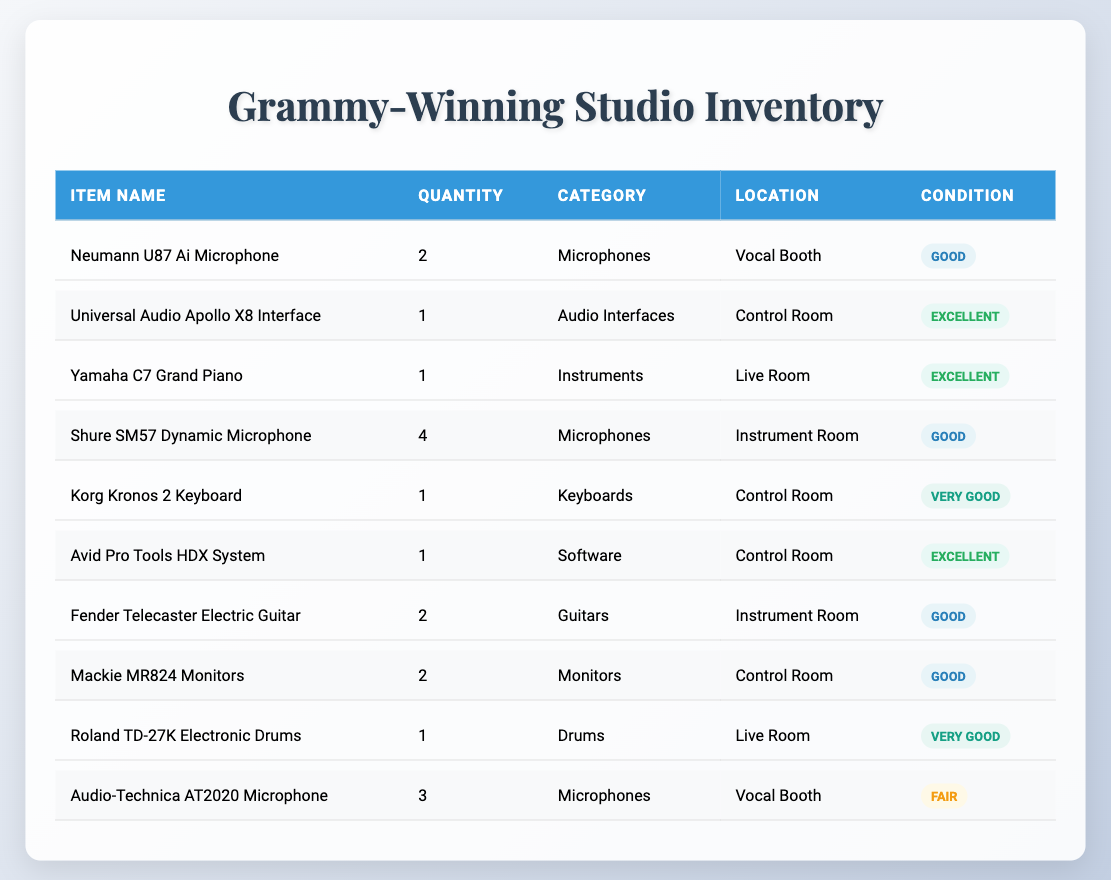What microphones are available in the Vocal Booth? The table lists two microphones in the Vocal Booth: Neumann U87 Ai Microphone (quantity 2) and Audio-Technica AT2020 Microphone (quantity 3).
Answer: Neumann U87 Ai Microphone and Audio-Technica AT2020 Microphone How many audio interfaces are there in the studio? There is 1 audio interface listed in the studio, which is the Universal Audio Apollo X8 Interface.
Answer: 1 What is the total quantity of instruments available? The total quantity includes the Yamaha C7 Grand Piano (1), Korg Kronos 2 Keyboard (1), and the total from all items classified under instruments, which is 1 (piano) + 1 (keyboard) = 2.
Answer: 2 Are there any microphones in fair condition? The table shows the Audio-Technica AT2020 Microphone as the only microphone in fair condition.
Answer: Yes Which item has the best condition among the listed equipment? Analyzing the conditions, the Universal Audio Apollo X8 Interface, Yamaha C7 Grand Piano, Avid Pro Tools HDX System, and Korg Kronos 2 Keyboard are all reported in excellent condition, but their quantities vary. Hence, in terms of a unique item, we could refer to any one of those named.
Answer: Universal Audio Apollo X8 Interface How many more microphones do we have compared to keyboards? The table indicates 9 microphones (2 Neumann U87 + 4 Shure SM57 + 3 Audio-Technica AT2020), and 1 keyboard (Korg Kronos). The difference is 9 - 1 = 8.
Answer: 8 Do we have any electronic drums, and if so, where are they located? Yes, the Roland TD-27K Electronic Drums are present in the Live Room.
Answer: Yes, in the Live Room What percentage of microphones are in good or better condition? To determine, we find that there are 9 microphones, out of which 2 are good, 4 are good, and 3 are in fair condition. Only 6 out of 9 microphones are good or better, which is (6/9)*100 = 66.67%.
Answer: Approximately 66.67% 